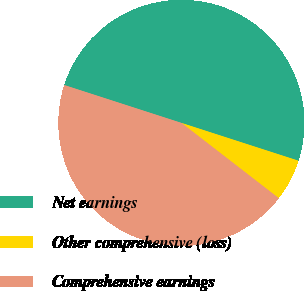Convert chart. <chart><loc_0><loc_0><loc_500><loc_500><pie_chart><fcel>Net earnings<fcel>Other comprehensive (loss)<fcel>Comprehensive earnings<nl><fcel>50.0%<fcel>5.5%<fcel>44.5%<nl></chart> 